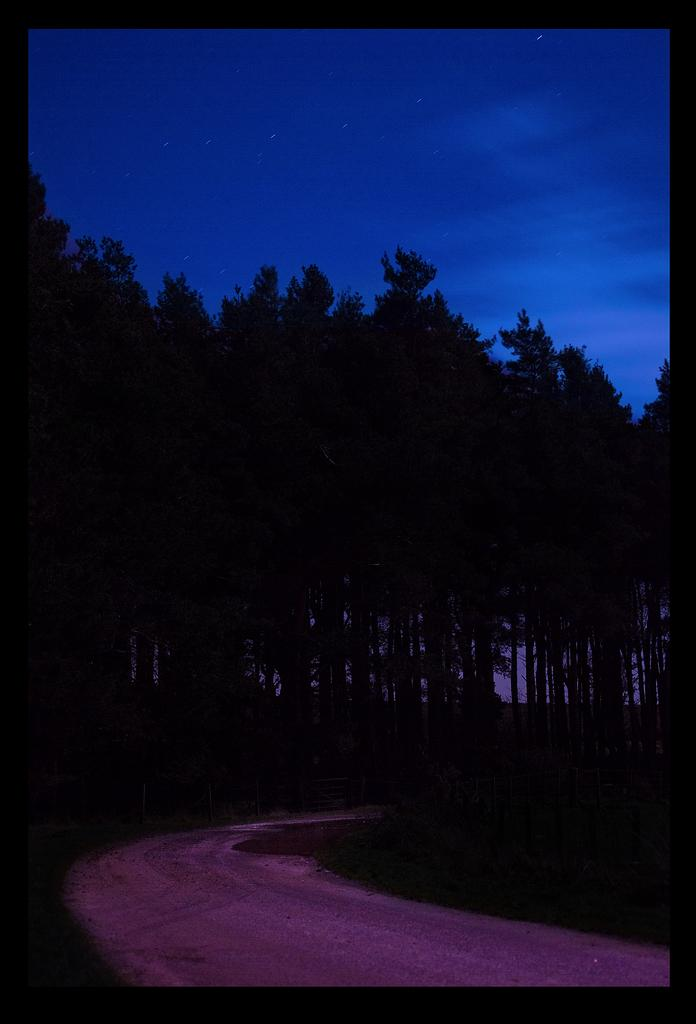What is the main subject of the image? The image depicts a road. What type of vegetation can be seen in the image? There is grass visible in the image. Are there any other natural elements present in the image? Yes, there are trees in the image. What can be seen in the background of the image? The sky is visible in the background of the image. How many straws are lying on the grass in the image? There are no straws present in the image. What type of frogs can be seen jumping across the road in the image? There are no frogs visible in the image; it only depicts a road, grass, trees, and the sky. 